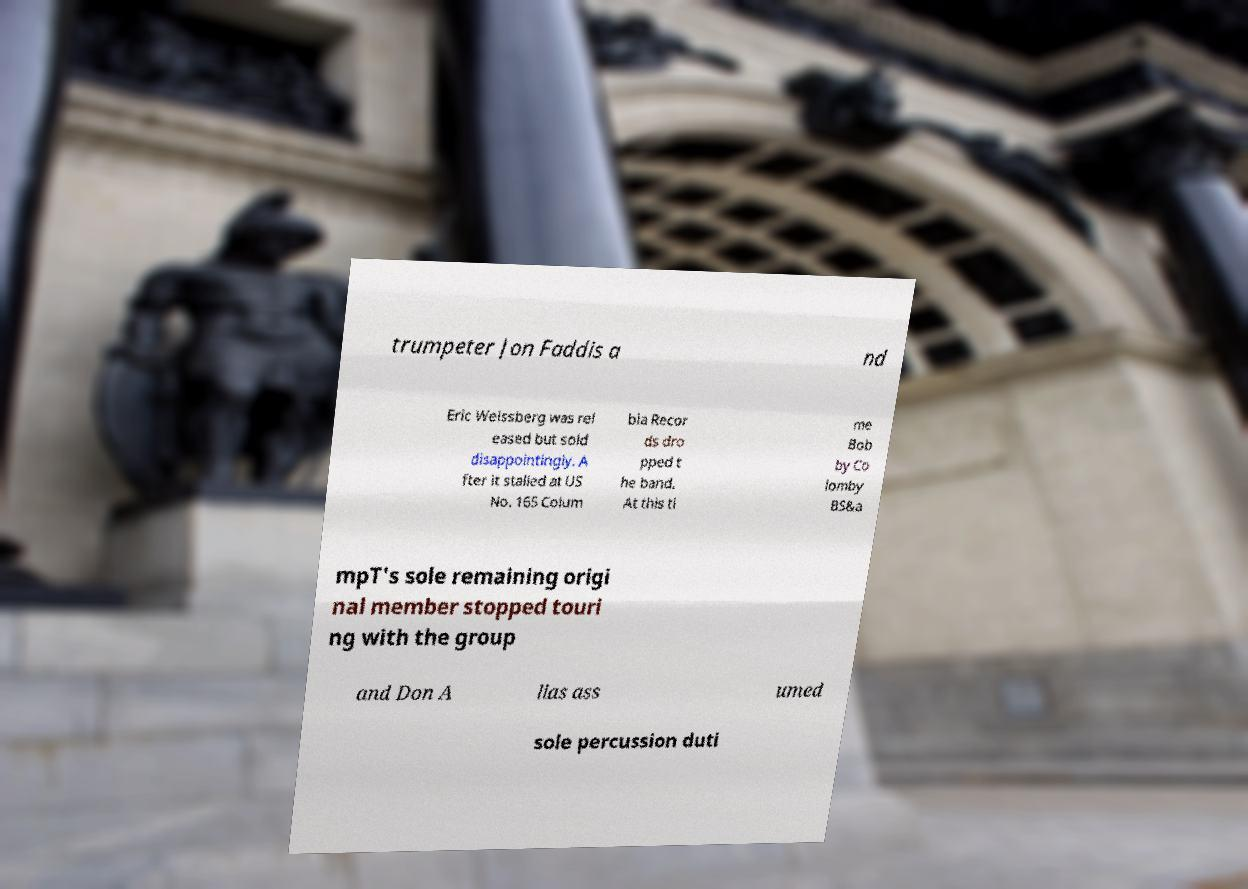What messages or text are displayed in this image? I need them in a readable, typed format. trumpeter Jon Faddis a nd Eric Weissberg was rel eased but sold disappointingly. A fter it stalled at US No. 165 Colum bia Recor ds dro pped t he band. At this ti me Bob by Co lomby BS&a mpT's sole remaining origi nal member stopped touri ng with the group and Don A lias ass umed sole percussion duti 